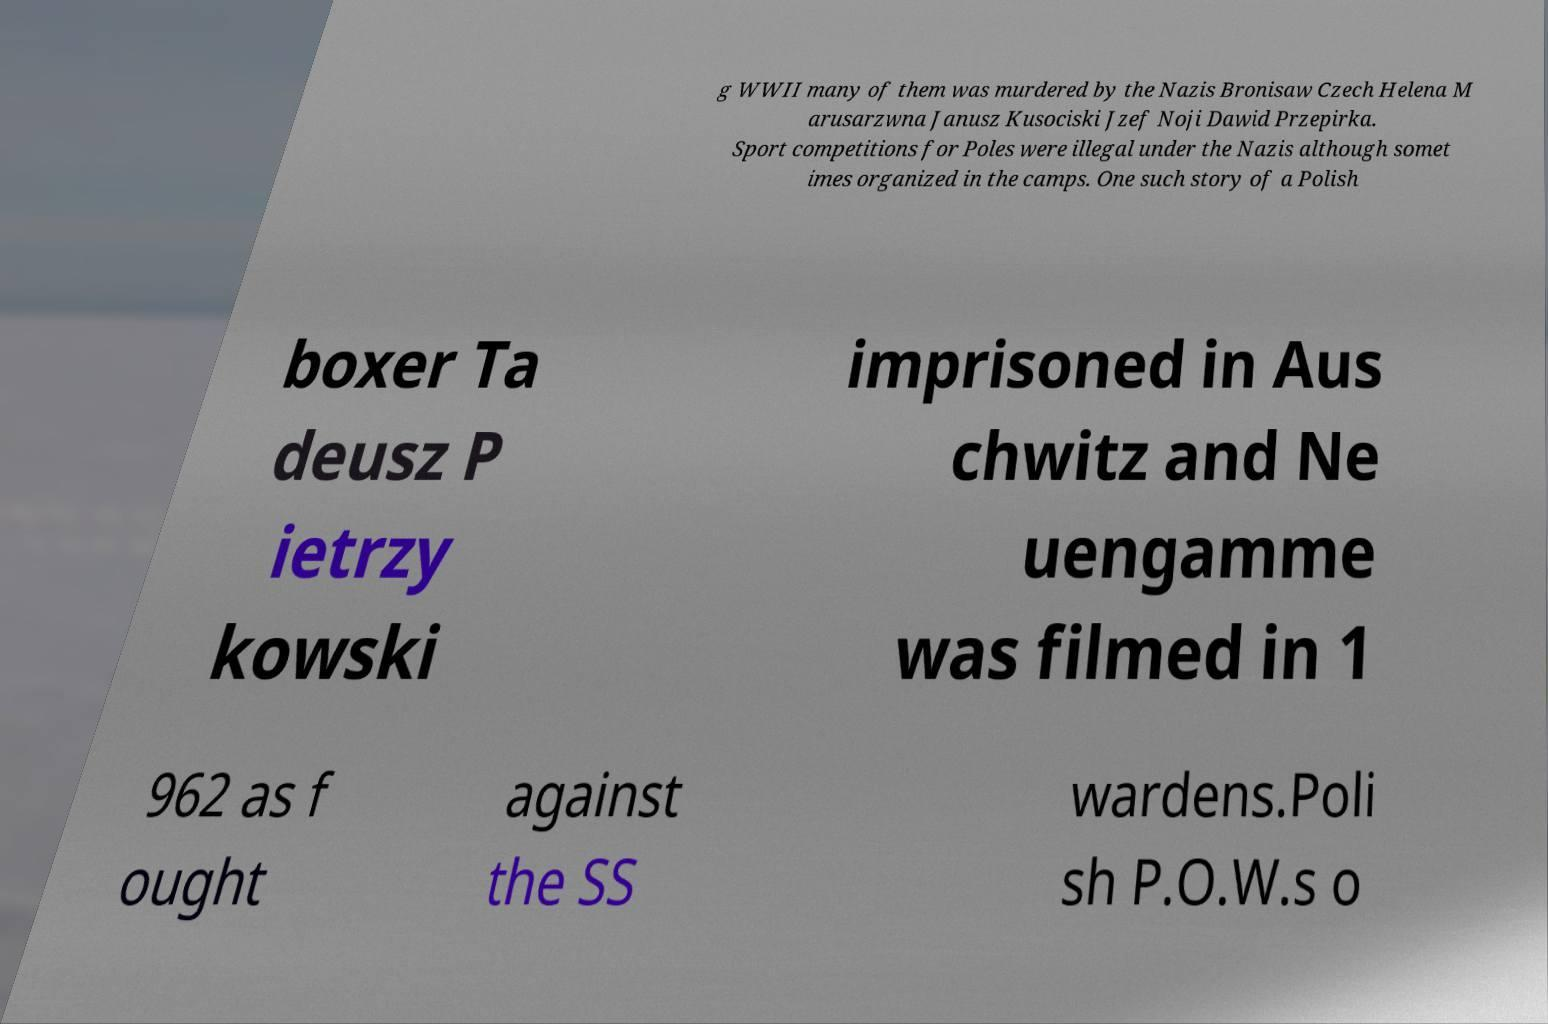There's text embedded in this image that I need extracted. Can you transcribe it verbatim? g WWII many of them was murdered by the Nazis Bronisaw Czech Helena M arusarzwna Janusz Kusociski Jzef Noji Dawid Przepirka. Sport competitions for Poles were illegal under the Nazis although somet imes organized in the camps. One such story of a Polish boxer Ta deusz P ietrzy kowski imprisoned in Aus chwitz and Ne uengamme was filmed in 1 962 as f ought against the SS wardens.Poli sh P.O.W.s o 